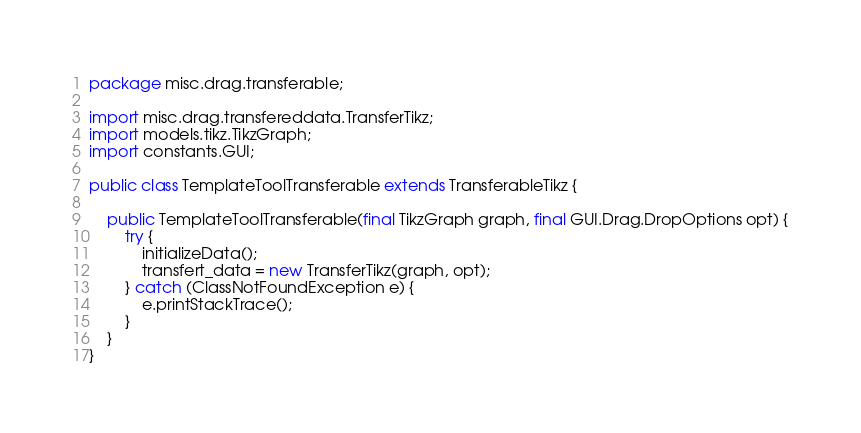<code> <loc_0><loc_0><loc_500><loc_500><_Java_>package misc.drag.transferable;

import misc.drag.transfereddata.TransferTikz;
import models.tikz.TikzGraph;
import constants.GUI;

public class TemplateToolTransferable extends TransferableTikz {

    public TemplateToolTransferable(final TikzGraph graph, final GUI.Drag.DropOptions opt) {
        try {
            initializeData();
            transfert_data = new TransferTikz(graph, opt);
        } catch (ClassNotFoundException e) {
            e.printStackTrace();
        }
    }
}
</code> 